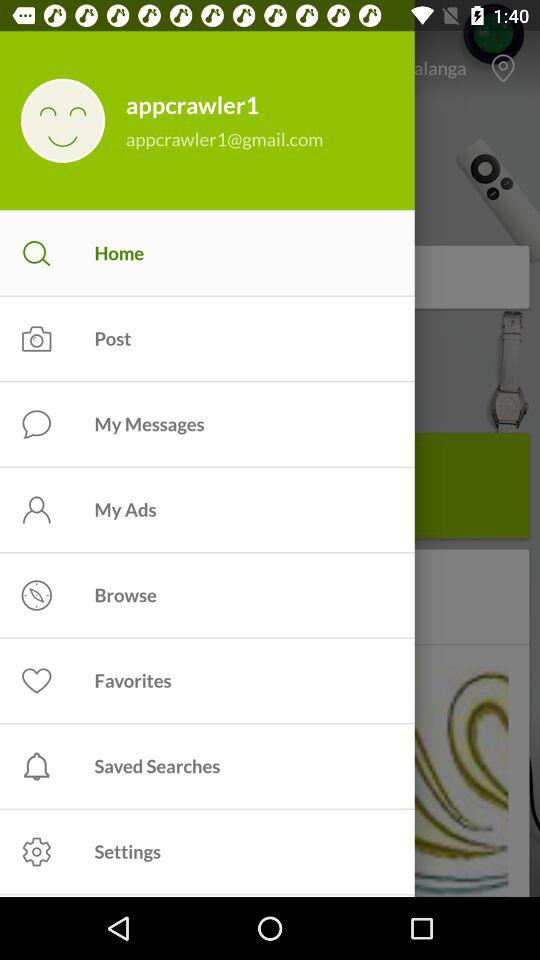What is the selected option? The selected option is "Home". 